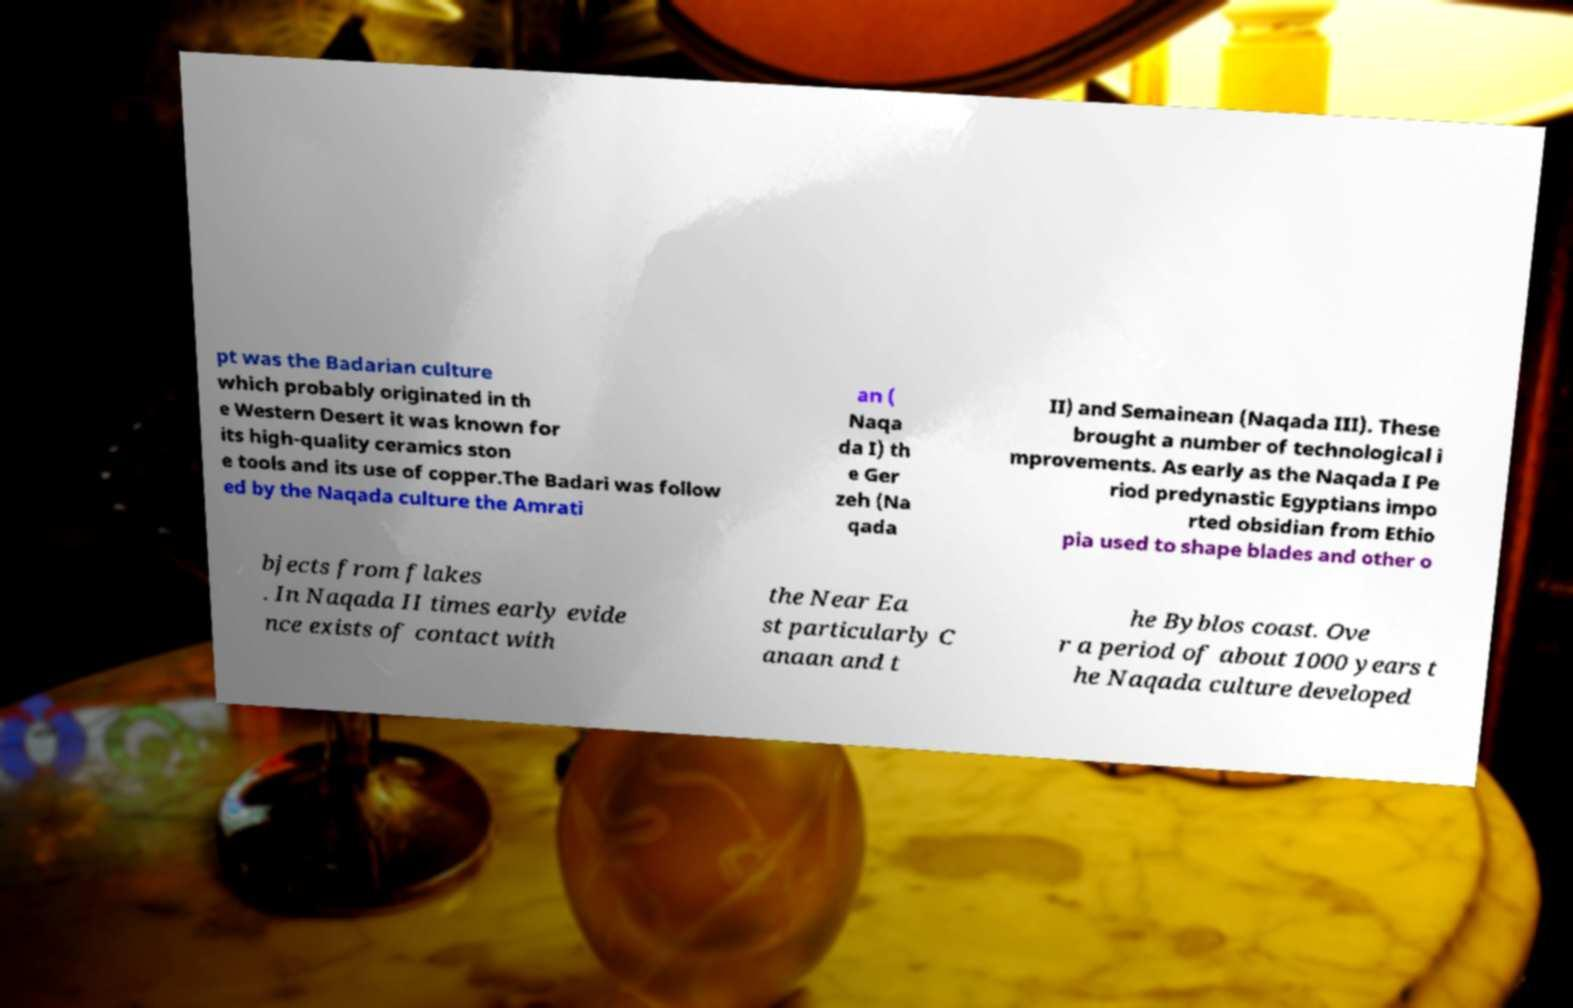Could you extract and type out the text from this image? pt was the Badarian culture which probably originated in th e Western Desert it was known for its high-quality ceramics ston e tools and its use of copper.The Badari was follow ed by the Naqada culture the Amrati an ( Naqa da I) th e Ger zeh (Na qada II) and Semainean (Naqada III). These brought a number of technological i mprovements. As early as the Naqada I Pe riod predynastic Egyptians impo rted obsidian from Ethio pia used to shape blades and other o bjects from flakes . In Naqada II times early evide nce exists of contact with the Near Ea st particularly C anaan and t he Byblos coast. Ove r a period of about 1000 years t he Naqada culture developed 